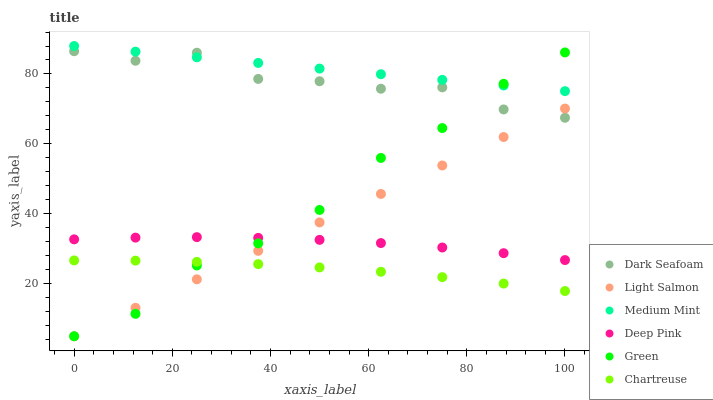Does Chartreuse have the minimum area under the curve?
Answer yes or no. Yes. Does Medium Mint have the maximum area under the curve?
Answer yes or no. Yes. Does Light Salmon have the minimum area under the curve?
Answer yes or no. No. Does Light Salmon have the maximum area under the curve?
Answer yes or no. No. Is Light Salmon the smoothest?
Answer yes or no. Yes. Is Green the roughest?
Answer yes or no. Yes. Is Deep Pink the smoothest?
Answer yes or no. No. Is Deep Pink the roughest?
Answer yes or no. No. Does Light Salmon have the lowest value?
Answer yes or no. Yes. Does Deep Pink have the lowest value?
Answer yes or no. No. Does Medium Mint have the highest value?
Answer yes or no. Yes. Does Light Salmon have the highest value?
Answer yes or no. No. Is Light Salmon less than Medium Mint?
Answer yes or no. Yes. Is Dark Seafoam greater than Chartreuse?
Answer yes or no. Yes. Does Dark Seafoam intersect Green?
Answer yes or no. Yes. Is Dark Seafoam less than Green?
Answer yes or no. No. Is Dark Seafoam greater than Green?
Answer yes or no. No. Does Light Salmon intersect Medium Mint?
Answer yes or no. No. 